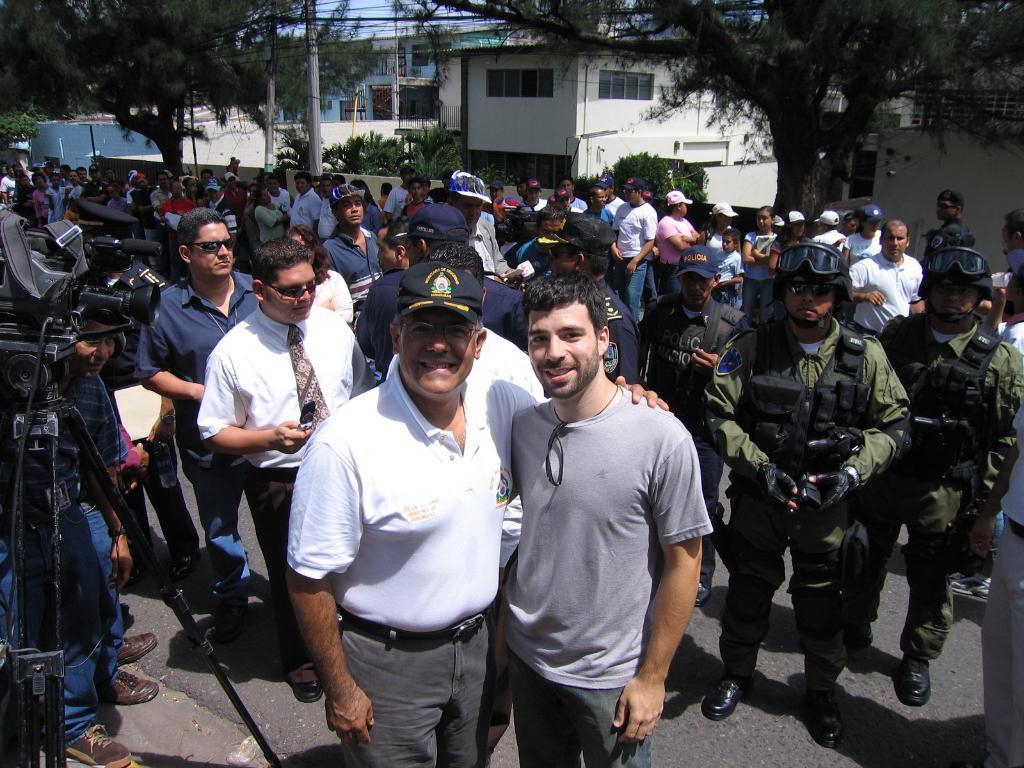How would you summarize this image in a sentence or two? In the foreground we can see two men standing on the road and they are smiling. In the background, we can see a group of people on the road. Here we can see a camera with stand on the left side. In the background, we can see the buildings and trees. 